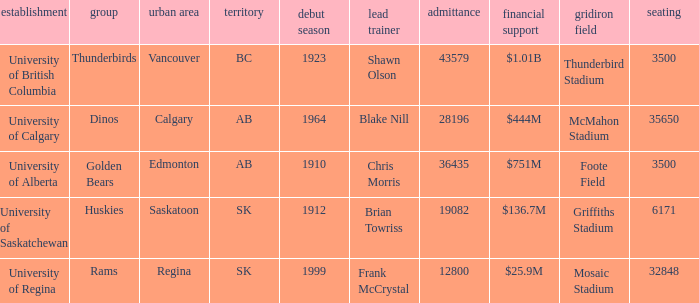What is the enrollment for Foote Field? 36435.0. 